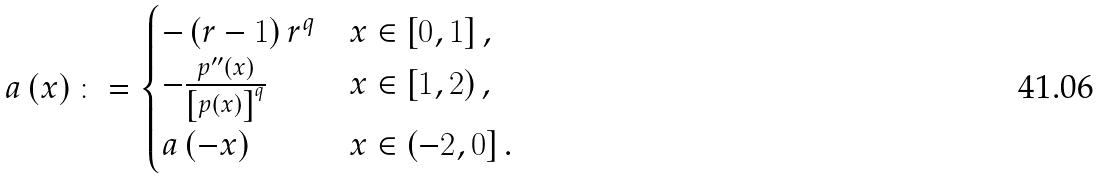<formula> <loc_0><loc_0><loc_500><loc_500>a \left ( x \right ) \colon = \begin{cases} - \left ( r - 1 \right ) r ^ { q } & x \in \left [ 0 , 1 \right ] , \\ - \frac { p ^ { \prime \prime } \left ( x \right ) } { \left [ p \left ( x \right ) \right ] ^ { q } } & x \in \left [ 1 , 2 \right ) , \\ a \left ( - x \right ) & x \in \left ( - 2 , 0 \right ] . \end{cases}</formula> 